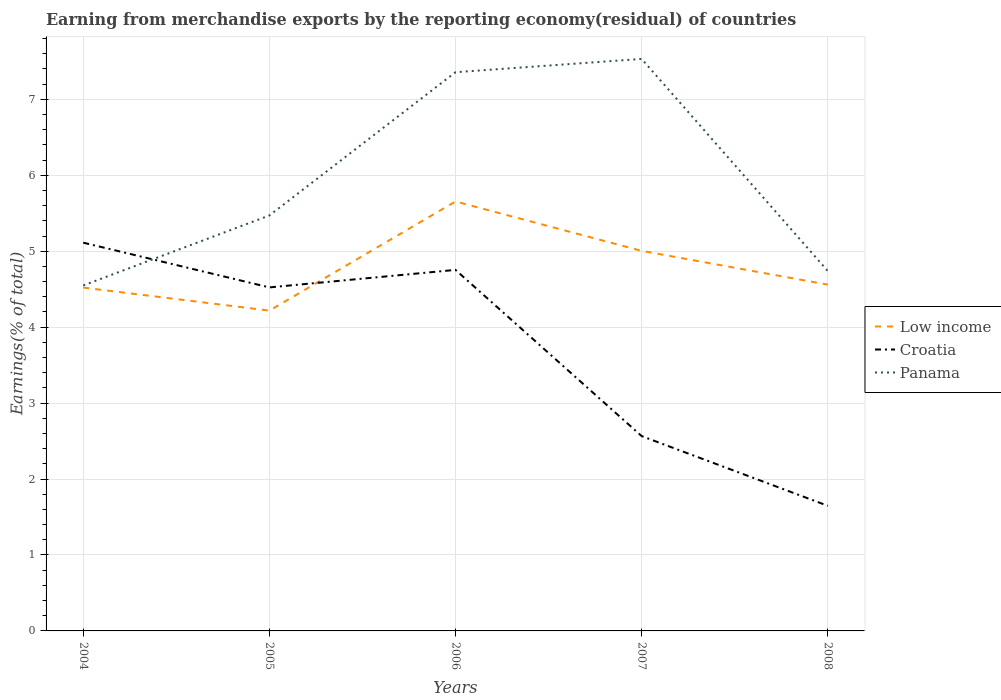Does the line corresponding to Low income intersect with the line corresponding to Croatia?
Ensure brevity in your answer.  Yes. Is the number of lines equal to the number of legend labels?
Ensure brevity in your answer.  Yes. Across all years, what is the maximum percentage of amount earned from merchandise exports in Croatia?
Your answer should be compact. 1.65. In which year was the percentage of amount earned from merchandise exports in Panama maximum?
Offer a terse response. 2004. What is the total percentage of amount earned from merchandise exports in Low income in the graph?
Your response must be concise. -0.04. What is the difference between the highest and the second highest percentage of amount earned from merchandise exports in Panama?
Give a very brief answer. 2.98. How many lines are there?
Make the answer very short. 3. How many years are there in the graph?
Ensure brevity in your answer.  5. What is the difference between two consecutive major ticks on the Y-axis?
Your answer should be compact. 1. Does the graph contain any zero values?
Provide a short and direct response. No. Does the graph contain grids?
Give a very brief answer. Yes. Where does the legend appear in the graph?
Provide a succinct answer. Center right. How many legend labels are there?
Make the answer very short. 3. What is the title of the graph?
Your answer should be compact. Earning from merchandise exports by the reporting economy(residual) of countries. What is the label or title of the X-axis?
Keep it short and to the point. Years. What is the label or title of the Y-axis?
Your answer should be very brief. Earnings(% of total). What is the Earnings(% of total) in Low income in 2004?
Provide a succinct answer. 4.52. What is the Earnings(% of total) of Croatia in 2004?
Provide a succinct answer. 5.11. What is the Earnings(% of total) of Panama in 2004?
Make the answer very short. 4.55. What is the Earnings(% of total) in Low income in 2005?
Keep it short and to the point. 4.22. What is the Earnings(% of total) in Croatia in 2005?
Your answer should be very brief. 4.52. What is the Earnings(% of total) of Panama in 2005?
Ensure brevity in your answer.  5.47. What is the Earnings(% of total) of Low income in 2006?
Your answer should be compact. 5.66. What is the Earnings(% of total) in Croatia in 2006?
Your answer should be compact. 4.75. What is the Earnings(% of total) in Panama in 2006?
Your answer should be very brief. 7.36. What is the Earnings(% of total) of Low income in 2007?
Your response must be concise. 5. What is the Earnings(% of total) in Croatia in 2007?
Provide a short and direct response. 2.57. What is the Earnings(% of total) of Panama in 2007?
Give a very brief answer. 7.53. What is the Earnings(% of total) in Low income in 2008?
Provide a short and direct response. 4.56. What is the Earnings(% of total) in Croatia in 2008?
Give a very brief answer. 1.65. What is the Earnings(% of total) in Panama in 2008?
Offer a very short reply. 4.74. Across all years, what is the maximum Earnings(% of total) in Low income?
Your answer should be compact. 5.66. Across all years, what is the maximum Earnings(% of total) in Croatia?
Ensure brevity in your answer.  5.11. Across all years, what is the maximum Earnings(% of total) of Panama?
Offer a terse response. 7.53. Across all years, what is the minimum Earnings(% of total) in Low income?
Offer a terse response. 4.22. Across all years, what is the minimum Earnings(% of total) of Croatia?
Offer a terse response. 1.65. Across all years, what is the minimum Earnings(% of total) in Panama?
Make the answer very short. 4.55. What is the total Earnings(% of total) of Low income in the graph?
Provide a short and direct response. 23.96. What is the total Earnings(% of total) of Croatia in the graph?
Provide a succinct answer. 18.6. What is the total Earnings(% of total) of Panama in the graph?
Make the answer very short. 29.65. What is the difference between the Earnings(% of total) in Low income in 2004 and that in 2005?
Your response must be concise. 0.3. What is the difference between the Earnings(% of total) in Croatia in 2004 and that in 2005?
Provide a succinct answer. 0.59. What is the difference between the Earnings(% of total) in Panama in 2004 and that in 2005?
Offer a very short reply. -0.92. What is the difference between the Earnings(% of total) in Low income in 2004 and that in 2006?
Give a very brief answer. -1.13. What is the difference between the Earnings(% of total) of Croatia in 2004 and that in 2006?
Provide a succinct answer. 0.36. What is the difference between the Earnings(% of total) in Panama in 2004 and that in 2006?
Provide a short and direct response. -2.81. What is the difference between the Earnings(% of total) of Low income in 2004 and that in 2007?
Provide a short and direct response. -0.48. What is the difference between the Earnings(% of total) of Croatia in 2004 and that in 2007?
Ensure brevity in your answer.  2.55. What is the difference between the Earnings(% of total) of Panama in 2004 and that in 2007?
Give a very brief answer. -2.98. What is the difference between the Earnings(% of total) in Low income in 2004 and that in 2008?
Keep it short and to the point. -0.04. What is the difference between the Earnings(% of total) in Croatia in 2004 and that in 2008?
Ensure brevity in your answer.  3.46. What is the difference between the Earnings(% of total) in Panama in 2004 and that in 2008?
Provide a short and direct response. -0.19. What is the difference between the Earnings(% of total) of Low income in 2005 and that in 2006?
Ensure brevity in your answer.  -1.44. What is the difference between the Earnings(% of total) of Croatia in 2005 and that in 2006?
Offer a very short reply. -0.23. What is the difference between the Earnings(% of total) of Panama in 2005 and that in 2006?
Give a very brief answer. -1.89. What is the difference between the Earnings(% of total) in Low income in 2005 and that in 2007?
Provide a short and direct response. -0.79. What is the difference between the Earnings(% of total) of Croatia in 2005 and that in 2007?
Your answer should be very brief. 1.96. What is the difference between the Earnings(% of total) of Panama in 2005 and that in 2007?
Give a very brief answer. -2.06. What is the difference between the Earnings(% of total) of Low income in 2005 and that in 2008?
Ensure brevity in your answer.  -0.34. What is the difference between the Earnings(% of total) in Croatia in 2005 and that in 2008?
Provide a short and direct response. 2.88. What is the difference between the Earnings(% of total) of Panama in 2005 and that in 2008?
Make the answer very short. 0.73. What is the difference between the Earnings(% of total) of Low income in 2006 and that in 2007?
Your answer should be very brief. 0.65. What is the difference between the Earnings(% of total) of Croatia in 2006 and that in 2007?
Give a very brief answer. 2.19. What is the difference between the Earnings(% of total) in Panama in 2006 and that in 2007?
Provide a succinct answer. -0.17. What is the difference between the Earnings(% of total) of Low income in 2006 and that in 2008?
Your answer should be compact. 1.09. What is the difference between the Earnings(% of total) of Croatia in 2006 and that in 2008?
Provide a succinct answer. 3.11. What is the difference between the Earnings(% of total) of Panama in 2006 and that in 2008?
Your answer should be very brief. 2.62. What is the difference between the Earnings(% of total) in Low income in 2007 and that in 2008?
Ensure brevity in your answer.  0.44. What is the difference between the Earnings(% of total) in Croatia in 2007 and that in 2008?
Give a very brief answer. 0.92. What is the difference between the Earnings(% of total) of Panama in 2007 and that in 2008?
Give a very brief answer. 2.79. What is the difference between the Earnings(% of total) of Low income in 2004 and the Earnings(% of total) of Croatia in 2005?
Offer a very short reply. -0. What is the difference between the Earnings(% of total) of Low income in 2004 and the Earnings(% of total) of Panama in 2005?
Offer a very short reply. -0.95. What is the difference between the Earnings(% of total) of Croatia in 2004 and the Earnings(% of total) of Panama in 2005?
Your response must be concise. -0.36. What is the difference between the Earnings(% of total) of Low income in 2004 and the Earnings(% of total) of Croatia in 2006?
Your answer should be very brief. -0.23. What is the difference between the Earnings(% of total) in Low income in 2004 and the Earnings(% of total) in Panama in 2006?
Your answer should be compact. -2.84. What is the difference between the Earnings(% of total) of Croatia in 2004 and the Earnings(% of total) of Panama in 2006?
Your answer should be compact. -2.24. What is the difference between the Earnings(% of total) in Low income in 2004 and the Earnings(% of total) in Croatia in 2007?
Your response must be concise. 1.96. What is the difference between the Earnings(% of total) in Low income in 2004 and the Earnings(% of total) in Panama in 2007?
Give a very brief answer. -3.01. What is the difference between the Earnings(% of total) of Croatia in 2004 and the Earnings(% of total) of Panama in 2007?
Make the answer very short. -2.42. What is the difference between the Earnings(% of total) in Low income in 2004 and the Earnings(% of total) in Croatia in 2008?
Make the answer very short. 2.87. What is the difference between the Earnings(% of total) in Low income in 2004 and the Earnings(% of total) in Panama in 2008?
Keep it short and to the point. -0.22. What is the difference between the Earnings(% of total) of Croatia in 2004 and the Earnings(% of total) of Panama in 2008?
Keep it short and to the point. 0.37. What is the difference between the Earnings(% of total) in Low income in 2005 and the Earnings(% of total) in Croatia in 2006?
Give a very brief answer. -0.54. What is the difference between the Earnings(% of total) in Low income in 2005 and the Earnings(% of total) in Panama in 2006?
Keep it short and to the point. -3.14. What is the difference between the Earnings(% of total) of Croatia in 2005 and the Earnings(% of total) of Panama in 2006?
Offer a terse response. -2.83. What is the difference between the Earnings(% of total) in Low income in 2005 and the Earnings(% of total) in Croatia in 2007?
Give a very brief answer. 1.65. What is the difference between the Earnings(% of total) of Low income in 2005 and the Earnings(% of total) of Panama in 2007?
Provide a short and direct response. -3.31. What is the difference between the Earnings(% of total) in Croatia in 2005 and the Earnings(% of total) in Panama in 2007?
Your answer should be very brief. -3.01. What is the difference between the Earnings(% of total) of Low income in 2005 and the Earnings(% of total) of Croatia in 2008?
Give a very brief answer. 2.57. What is the difference between the Earnings(% of total) in Low income in 2005 and the Earnings(% of total) in Panama in 2008?
Offer a terse response. -0.52. What is the difference between the Earnings(% of total) of Croatia in 2005 and the Earnings(% of total) of Panama in 2008?
Give a very brief answer. -0.22. What is the difference between the Earnings(% of total) in Low income in 2006 and the Earnings(% of total) in Croatia in 2007?
Provide a succinct answer. 3.09. What is the difference between the Earnings(% of total) in Low income in 2006 and the Earnings(% of total) in Panama in 2007?
Ensure brevity in your answer.  -1.88. What is the difference between the Earnings(% of total) in Croatia in 2006 and the Earnings(% of total) in Panama in 2007?
Your answer should be very brief. -2.78. What is the difference between the Earnings(% of total) in Low income in 2006 and the Earnings(% of total) in Croatia in 2008?
Your answer should be compact. 4.01. What is the difference between the Earnings(% of total) in Low income in 2006 and the Earnings(% of total) in Panama in 2008?
Make the answer very short. 0.92. What is the difference between the Earnings(% of total) of Croatia in 2006 and the Earnings(% of total) of Panama in 2008?
Keep it short and to the point. 0.01. What is the difference between the Earnings(% of total) in Low income in 2007 and the Earnings(% of total) in Croatia in 2008?
Ensure brevity in your answer.  3.36. What is the difference between the Earnings(% of total) of Low income in 2007 and the Earnings(% of total) of Panama in 2008?
Offer a very short reply. 0.27. What is the difference between the Earnings(% of total) in Croatia in 2007 and the Earnings(% of total) in Panama in 2008?
Your response must be concise. -2.17. What is the average Earnings(% of total) of Low income per year?
Provide a succinct answer. 4.79. What is the average Earnings(% of total) of Croatia per year?
Give a very brief answer. 3.72. What is the average Earnings(% of total) of Panama per year?
Offer a very short reply. 5.93. In the year 2004, what is the difference between the Earnings(% of total) in Low income and Earnings(% of total) in Croatia?
Make the answer very short. -0.59. In the year 2004, what is the difference between the Earnings(% of total) in Low income and Earnings(% of total) in Panama?
Offer a very short reply. -0.03. In the year 2004, what is the difference between the Earnings(% of total) in Croatia and Earnings(% of total) in Panama?
Your answer should be very brief. 0.56. In the year 2005, what is the difference between the Earnings(% of total) of Low income and Earnings(% of total) of Croatia?
Give a very brief answer. -0.31. In the year 2005, what is the difference between the Earnings(% of total) of Low income and Earnings(% of total) of Panama?
Offer a terse response. -1.25. In the year 2005, what is the difference between the Earnings(% of total) of Croatia and Earnings(% of total) of Panama?
Give a very brief answer. -0.95. In the year 2006, what is the difference between the Earnings(% of total) in Low income and Earnings(% of total) in Croatia?
Offer a very short reply. 0.9. In the year 2006, what is the difference between the Earnings(% of total) of Low income and Earnings(% of total) of Panama?
Give a very brief answer. -1.7. In the year 2006, what is the difference between the Earnings(% of total) of Croatia and Earnings(% of total) of Panama?
Your response must be concise. -2.6. In the year 2007, what is the difference between the Earnings(% of total) in Low income and Earnings(% of total) in Croatia?
Your answer should be compact. 2.44. In the year 2007, what is the difference between the Earnings(% of total) of Low income and Earnings(% of total) of Panama?
Provide a succinct answer. -2.53. In the year 2007, what is the difference between the Earnings(% of total) in Croatia and Earnings(% of total) in Panama?
Make the answer very short. -4.97. In the year 2008, what is the difference between the Earnings(% of total) of Low income and Earnings(% of total) of Croatia?
Your answer should be compact. 2.91. In the year 2008, what is the difference between the Earnings(% of total) of Low income and Earnings(% of total) of Panama?
Offer a very short reply. -0.18. In the year 2008, what is the difference between the Earnings(% of total) in Croatia and Earnings(% of total) in Panama?
Your response must be concise. -3.09. What is the ratio of the Earnings(% of total) of Low income in 2004 to that in 2005?
Your answer should be compact. 1.07. What is the ratio of the Earnings(% of total) of Croatia in 2004 to that in 2005?
Keep it short and to the point. 1.13. What is the ratio of the Earnings(% of total) of Panama in 2004 to that in 2005?
Your answer should be compact. 0.83. What is the ratio of the Earnings(% of total) in Low income in 2004 to that in 2006?
Provide a succinct answer. 0.8. What is the ratio of the Earnings(% of total) in Croatia in 2004 to that in 2006?
Keep it short and to the point. 1.08. What is the ratio of the Earnings(% of total) in Panama in 2004 to that in 2006?
Keep it short and to the point. 0.62. What is the ratio of the Earnings(% of total) in Low income in 2004 to that in 2007?
Your answer should be very brief. 0.9. What is the ratio of the Earnings(% of total) of Croatia in 2004 to that in 2007?
Ensure brevity in your answer.  1.99. What is the ratio of the Earnings(% of total) in Panama in 2004 to that in 2007?
Your answer should be very brief. 0.6. What is the ratio of the Earnings(% of total) in Croatia in 2004 to that in 2008?
Your answer should be compact. 3.1. What is the ratio of the Earnings(% of total) in Panama in 2004 to that in 2008?
Offer a very short reply. 0.96. What is the ratio of the Earnings(% of total) in Low income in 2005 to that in 2006?
Provide a succinct answer. 0.75. What is the ratio of the Earnings(% of total) in Croatia in 2005 to that in 2006?
Provide a succinct answer. 0.95. What is the ratio of the Earnings(% of total) in Panama in 2005 to that in 2006?
Provide a succinct answer. 0.74. What is the ratio of the Earnings(% of total) in Low income in 2005 to that in 2007?
Your answer should be compact. 0.84. What is the ratio of the Earnings(% of total) of Croatia in 2005 to that in 2007?
Offer a very short reply. 1.76. What is the ratio of the Earnings(% of total) of Panama in 2005 to that in 2007?
Your answer should be compact. 0.73. What is the ratio of the Earnings(% of total) of Low income in 2005 to that in 2008?
Give a very brief answer. 0.92. What is the ratio of the Earnings(% of total) in Croatia in 2005 to that in 2008?
Your response must be concise. 2.75. What is the ratio of the Earnings(% of total) of Panama in 2005 to that in 2008?
Ensure brevity in your answer.  1.15. What is the ratio of the Earnings(% of total) in Low income in 2006 to that in 2007?
Your answer should be very brief. 1.13. What is the ratio of the Earnings(% of total) in Croatia in 2006 to that in 2007?
Your answer should be very brief. 1.85. What is the ratio of the Earnings(% of total) of Panama in 2006 to that in 2007?
Offer a very short reply. 0.98. What is the ratio of the Earnings(% of total) in Low income in 2006 to that in 2008?
Give a very brief answer. 1.24. What is the ratio of the Earnings(% of total) in Croatia in 2006 to that in 2008?
Your answer should be compact. 2.88. What is the ratio of the Earnings(% of total) of Panama in 2006 to that in 2008?
Make the answer very short. 1.55. What is the ratio of the Earnings(% of total) of Low income in 2007 to that in 2008?
Ensure brevity in your answer.  1.1. What is the ratio of the Earnings(% of total) in Croatia in 2007 to that in 2008?
Provide a succinct answer. 1.56. What is the ratio of the Earnings(% of total) of Panama in 2007 to that in 2008?
Make the answer very short. 1.59. What is the difference between the highest and the second highest Earnings(% of total) of Low income?
Provide a succinct answer. 0.65. What is the difference between the highest and the second highest Earnings(% of total) in Croatia?
Provide a succinct answer. 0.36. What is the difference between the highest and the second highest Earnings(% of total) in Panama?
Keep it short and to the point. 0.17. What is the difference between the highest and the lowest Earnings(% of total) in Low income?
Keep it short and to the point. 1.44. What is the difference between the highest and the lowest Earnings(% of total) in Croatia?
Your answer should be very brief. 3.46. What is the difference between the highest and the lowest Earnings(% of total) of Panama?
Your answer should be very brief. 2.98. 